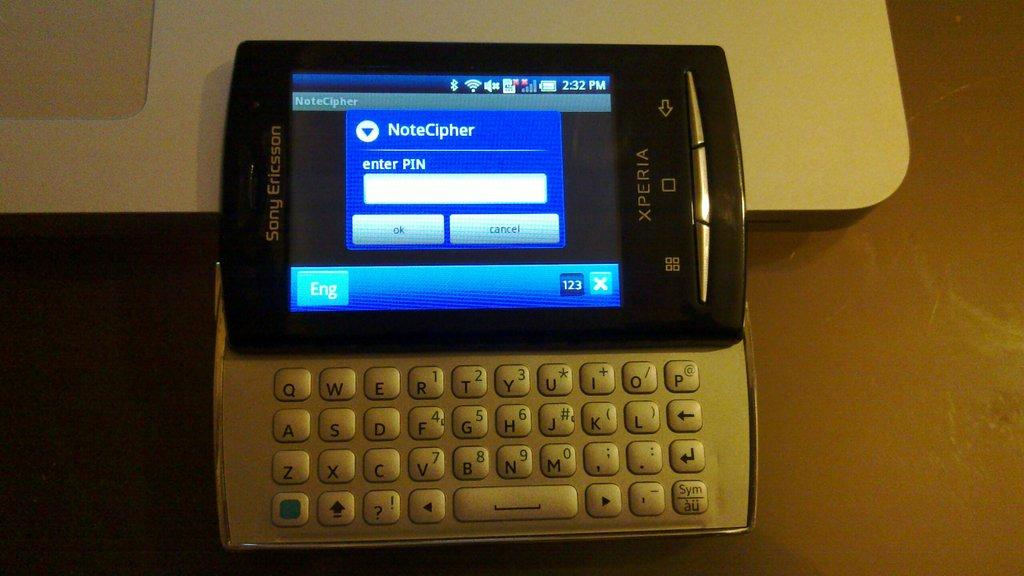Provide a one-sentence caption for the provided image. A computer with NoteCipher and a pin on it. 